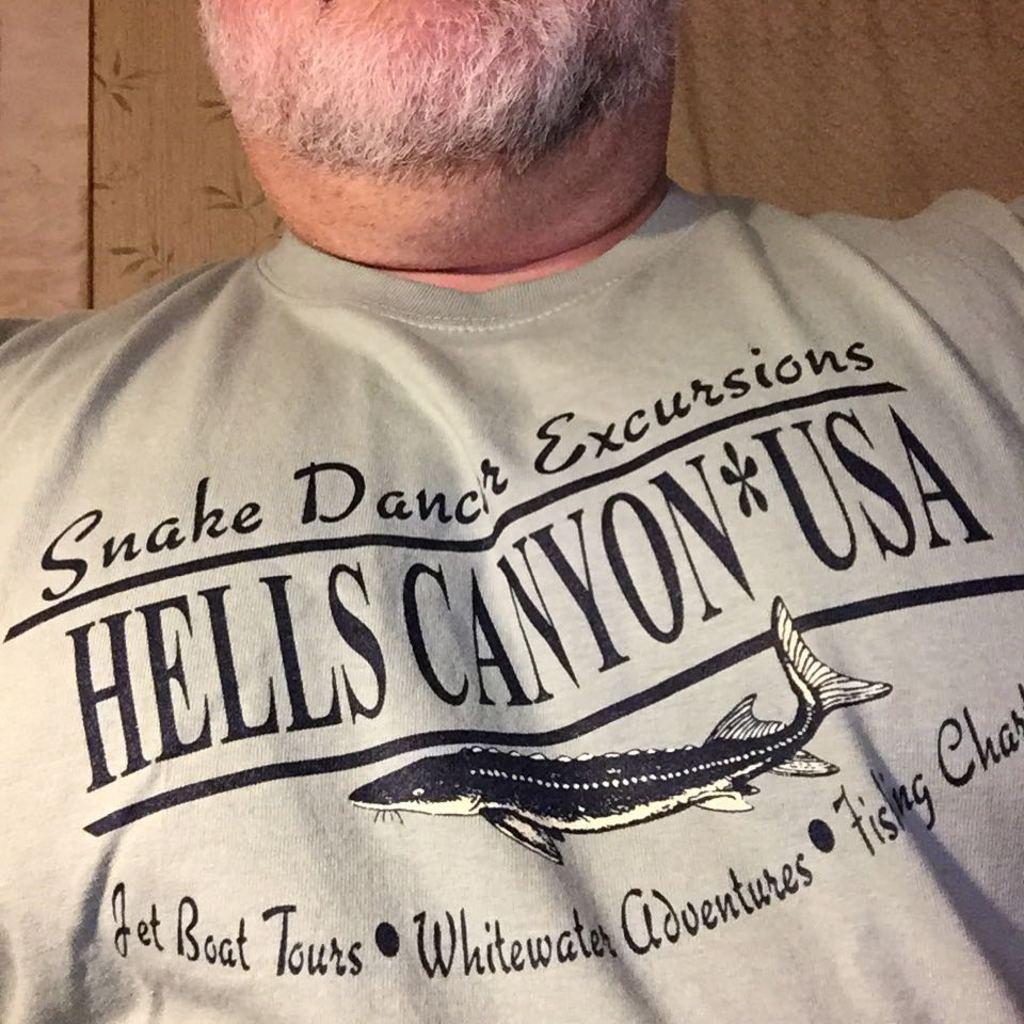In one or two sentences, can you explain what this image depicts? There is a person in the center of the image, it seems like a curtain in the background area. 